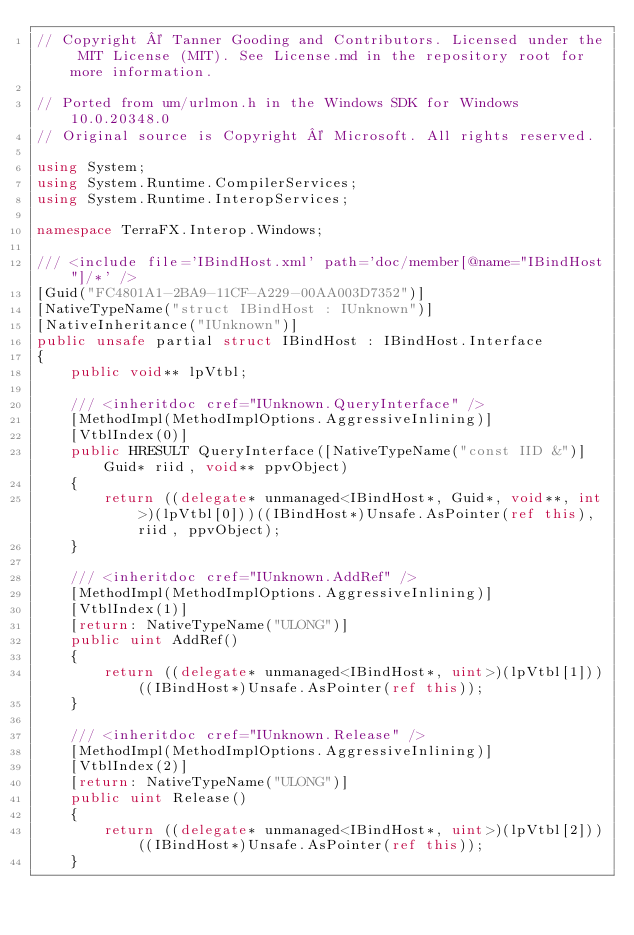<code> <loc_0><loc_0><loc_500><loc_500><_C#_>// Copyright © Tanner Gooding and Contributors. Licensed under the MIT License (MIT). See License.md in the repository root for more information.

// Ported from um/urlmon.h in the Windows SDK for Windows 10.0.20348.0
// Original source is Copyright © Microsoft. All rights reserved.

using System;
using System.Runtime.CompilerServices;
using System.Runtime.InteropServices;

namespace TerraFX.Interop.Windows;

/// <include file='IBindHost.xml' path='doc/member[@name="IBindHost"]/*' />
[Guid("FC4801A1-2BA9-11CF-A229-00AA003D7352")]
[NativeTypeName("struct IBindHost : IUnknown")]
[NativeInheritance("IUnknown")]
public unsafe partial struct IBindHost : IBindHost.Interface
{
    public void** lpVtbl;

    /// <inheritdoc cref="IUnknown.QueryInterface" />
    [MethodImpl(MethodImplOptions.AggressiveInlining)]
    [VtblIndex(0)]
    public HRESULT QueryInterface([NativeTypeName("const IID &")] Guid* riid, void** ppvObject)
    {
        return ((delegate* unmanaged<IBindHost*, Guid*, void**, int>)(lpVtbl[0]))((IBindHost*)Unsafe.AsPointer(ref this), riid, ppvObject);
    }

    /// <inheritdoc cref="IUnknown.AddRef" />
    [MethodImpl(MethodImplOptions.AggressiveInlining)]
    [VtblIndex(1)]
    [return: NativeTypeName("ULONG")]
    public uint AddRef()
    {
        return ((delegate* unmanaged<IBindHost*, uint>)(lpVtbl[1]))((IBindHost*)Unsafe.AsPointer(ref this));
    }

    /// <inheritdoc cref="IUnknown.Release" />
    [MethodImpl(MethodImplOptions.AggressiveInlining)]
    [VtblIndex(2)]
    [return: NativeTypeName("ULONG")]
    public uint Release()
    {
        return ((delegate* unmanaged<IBindHost*, uint>)(lpVtbl[2]))((IBindHost*)Unsafe.AsPointer(ref this));
    }
</code> 